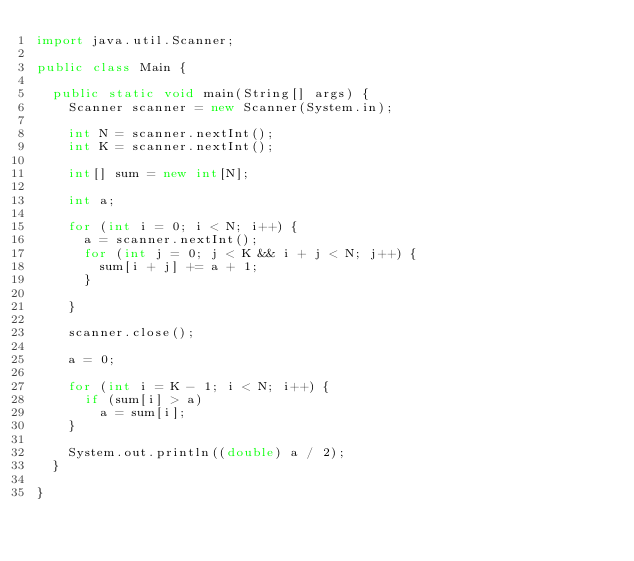<code> <loc_0><loc_0><loc_500><loc_500><_Java_>import java.util.Scanner;

public class Main {

	public static void main(String[] args) {
		Scanner scanner = new Scanner(System.in);

		int N = scanner.nextInt();
		int K = scanner.nextInt();

		int[] sum = new int[N];

		int a;

		for (int i = 0; i < N; i++) {
			a = scanner.nextInt();
			for (int j = 0; j < K && i + j < N; j++) {
				sum[i + j] += a + 1;
			}

		}

		scanner.close();

		a = 0;

		for (int i = K - 1; i < N; i++) {
			if (sum[i] > a)
				a = sum[i];
		}

		System.out.println((double) a / 2);
	}

}
</code> 